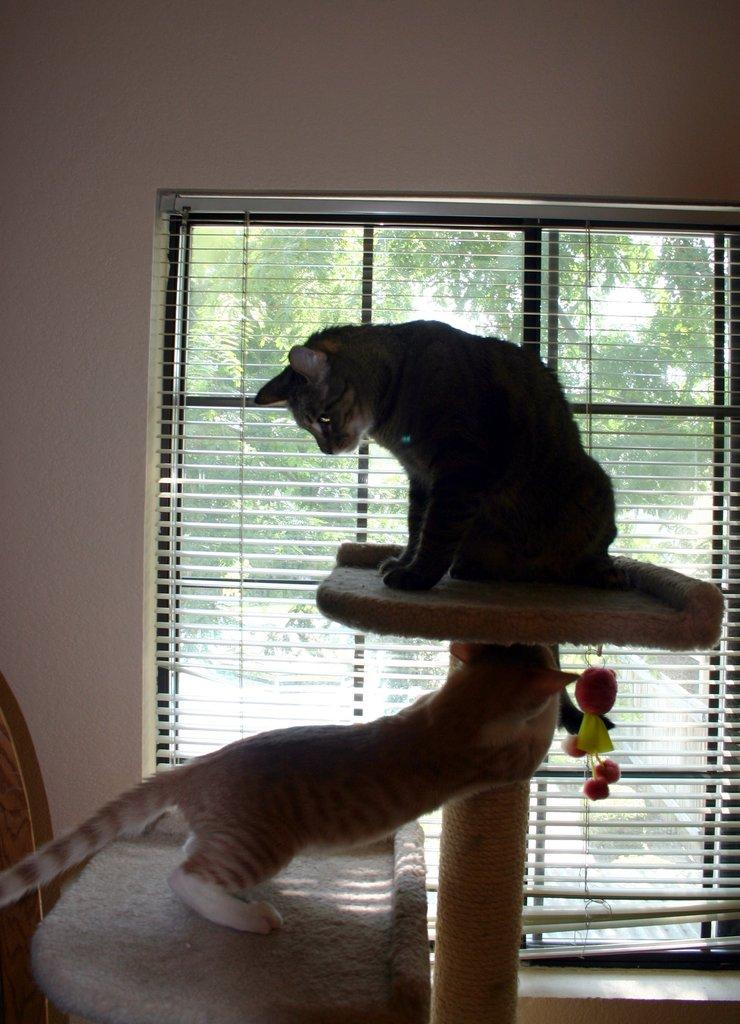What type of animals are in the image? There are cats in the image. What type of furniture is in the image? There is a table in the image. What type of window treatment is in the image? There are window blinds in the image. What type of vegetation is in the image? There are trees in the image. What type of shoe is the cat wearing in the image? There are no shoes present in the image, and the cats are not wearing any. 